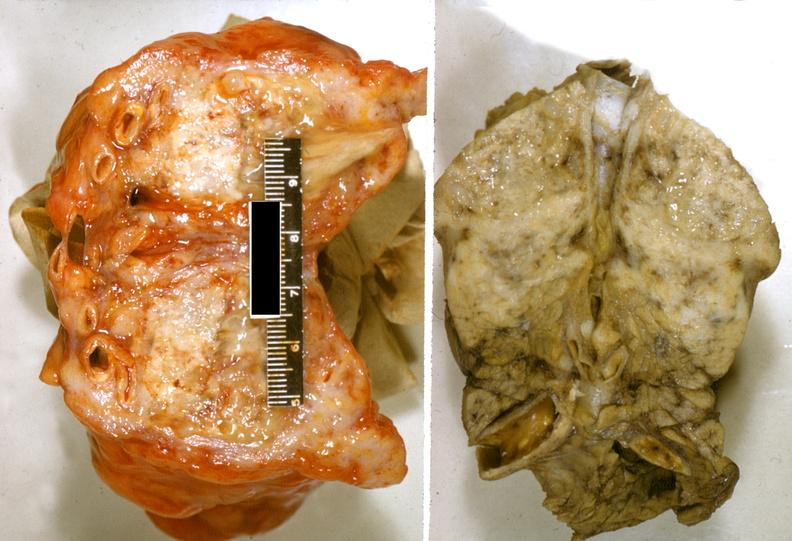does papilloma on vocal cord show adenocarcinoma, tail of pancreas?
Answer the question using a single word or phrase. No 